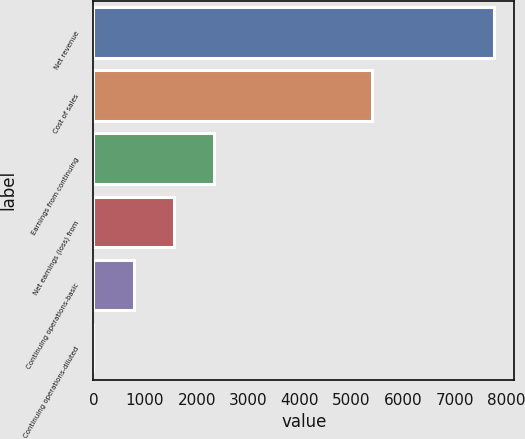Convert chart to OTSL. <chart><loc_0><loc_0><loc_500><loc_500><bar_chart><fcel>Net revenue<fcel>Cost of sales<fcel>Earnings from continuing<fcel>Net earnings (loss) from<fcel>Continuing operations-basic<fcel>Continuing operations-diluted<nl><fcel>7764<fcel>5399<fcel>2329.4<fcel>1553.03<fcel>776.66<fcel>0.29<nl></chart> 